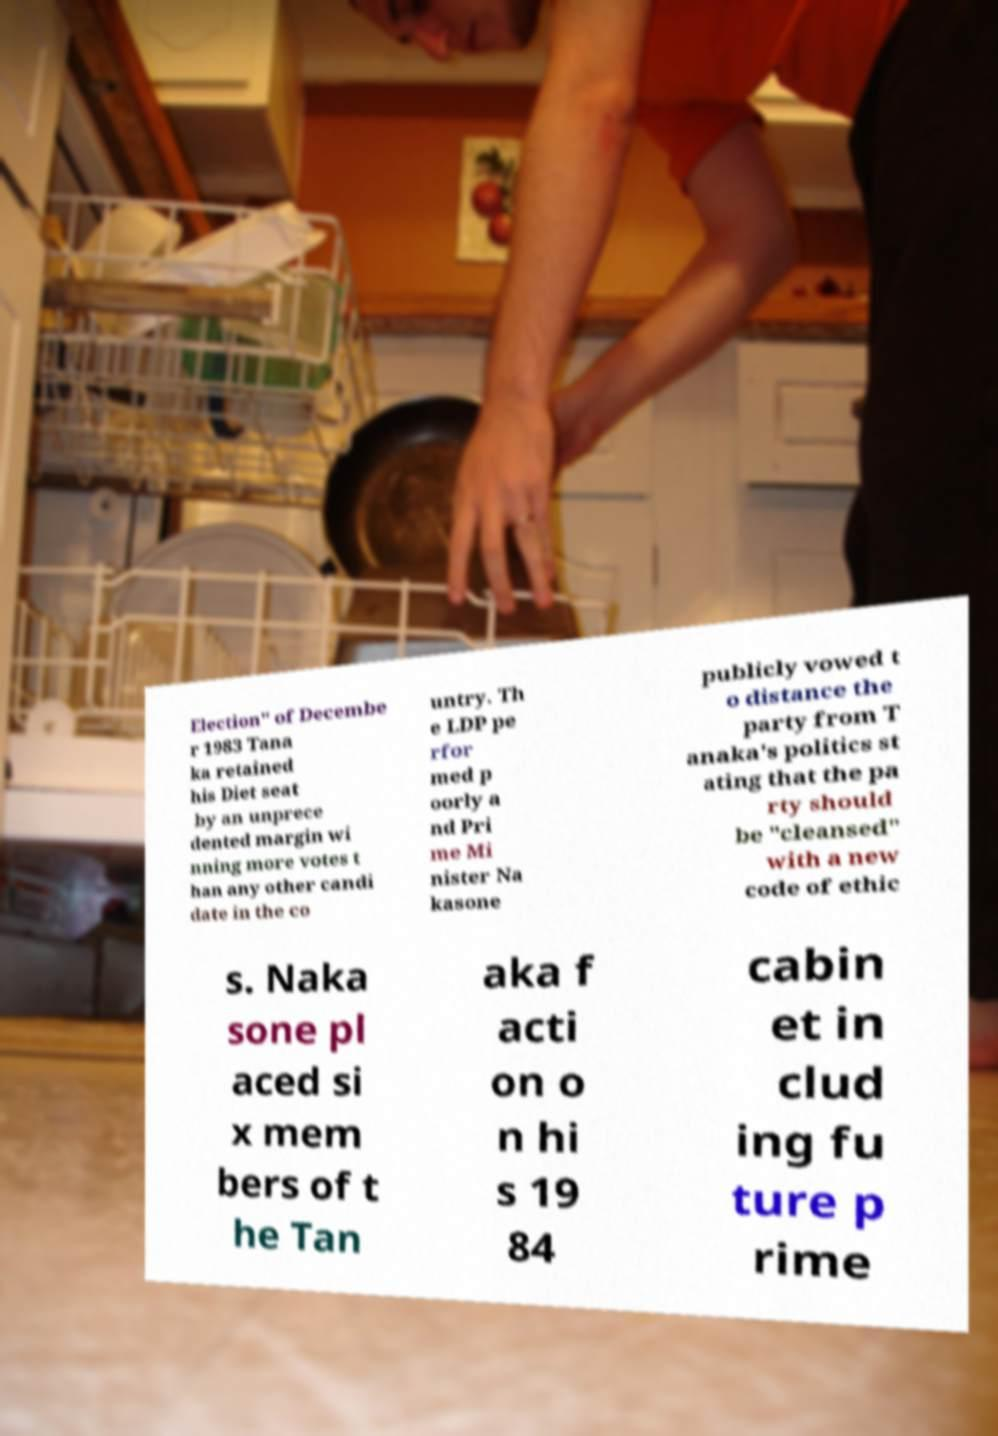Could you extract and type out the text from this image? Election" of Decembe r 1983 Tana ka retained his Diet seat by an unprece dented margin wi nning more votes t han any other candi date in the co untry. Th e LDP pe rfor med p oorly a nd Pri me Mi nister Na kasone publicly vowed t o distance the party from T anaka's politics st ating that the pa rty should be "cleansed" with a new code of ethic s. Naka sone pl aced si x mem bers of t he Tan aka f acti on o n hi s 19 84 cabin et in clud ing fu ture p rime 